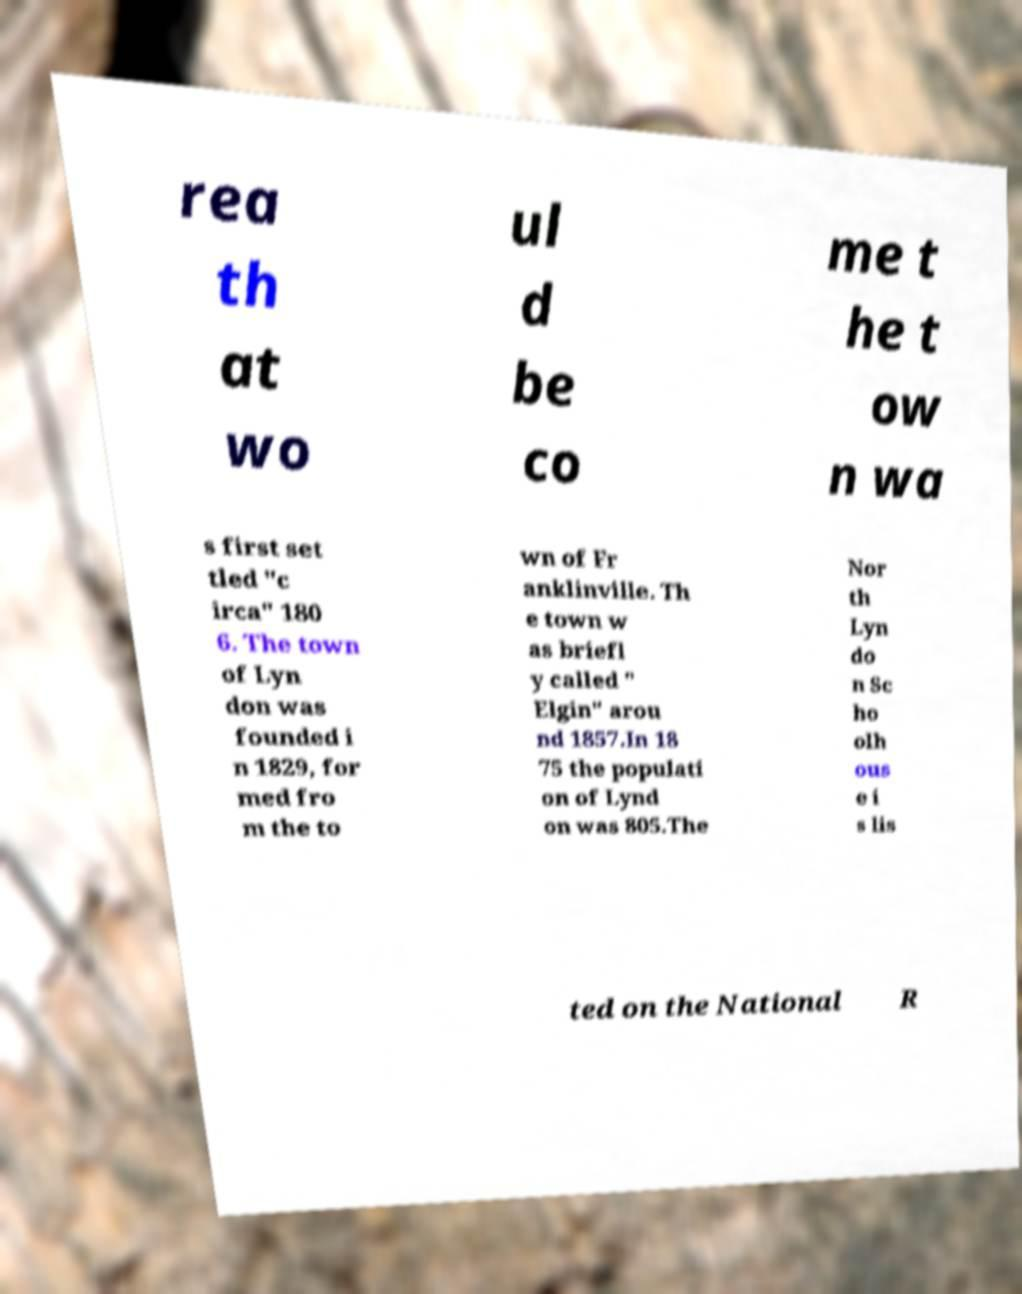Could you assist in decoding the text presented in this image and type it out clearly? rea th at wo ul d be co me t he t ow n wa s first set tled "c irca" 180 6. The town of Lyn don was founded i n 1829, for med fro m the to wn of Fr anklinville. Th e town w as briefl y called " Elgin" arou nd 1857.In 18 75 the populati on of Lynd on was 805.The Nor th Lyn do n Sc ho olh ous e i s lis ted on the National R 